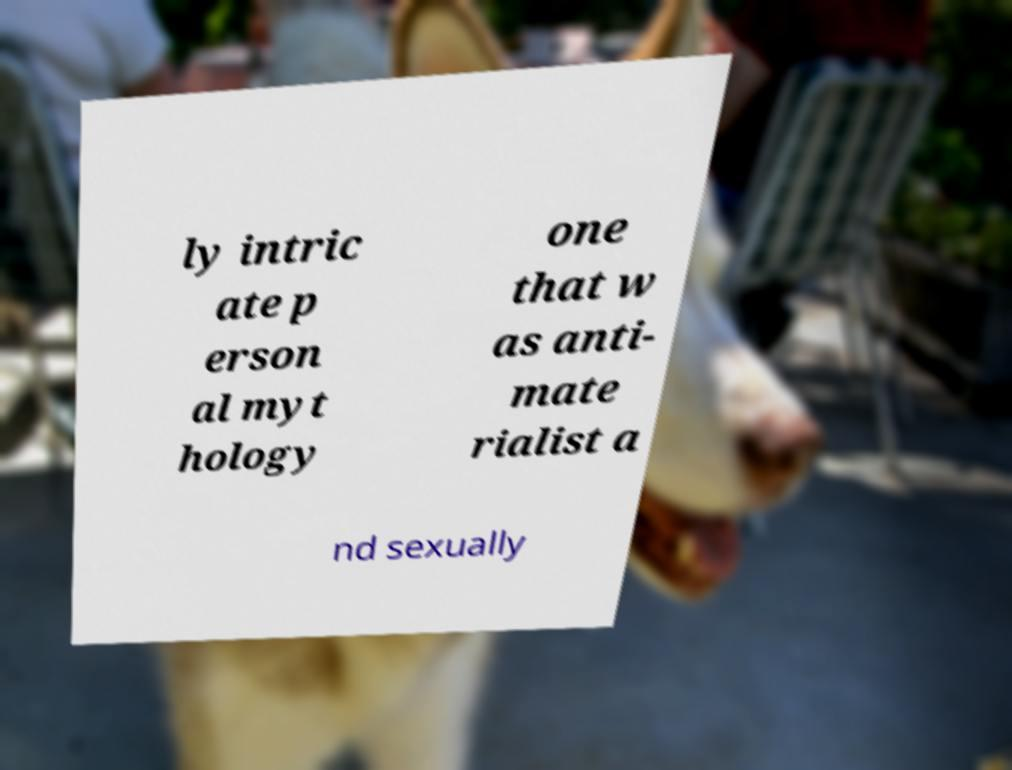Please read and relay the text visible in this image. What does it say? ly intric ate p erson al myt hology one that w as anti- mate rialist a nd sexually 